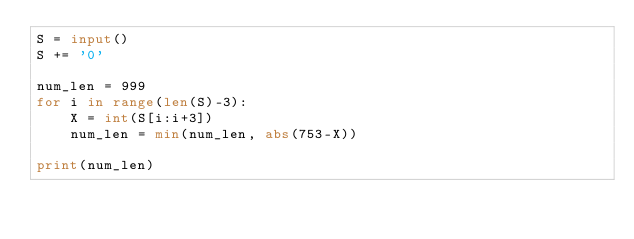Convert code to text. <code><loc_0><loc_0><loc_500><loc_500><_Python_>S = input()
S += '0'

num_len = 999
for i in range(len(S)-3):
    X = int(S[i:i+3])
    num_len = min(num_len, abs(753-X))

print(num_len)</code> 